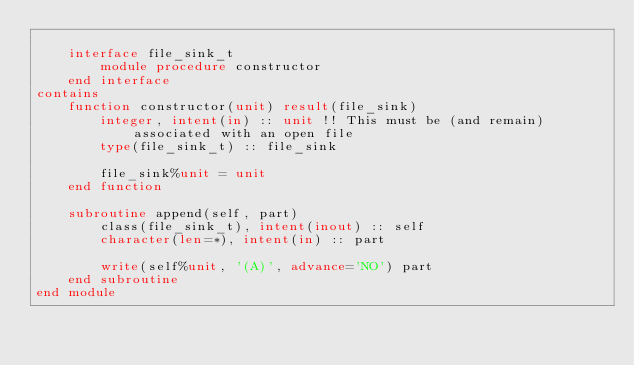<code> <loc_0><loc_0><loc_500><loc_500><_FORTRAN_>
    interface file_sink_t
        module procedure constructor
    end interface
contains
    function constructor(unit) result(file_sink)
        integer, intent(in) :: unit !! This must be (and remain) associated with an open file
        type(file_sink_t) :: file_sink

        file_sink%unit = unit
    end function

    subroutine append(self, part)
        class(file_sink_t), intent(inout) :: self
        character(len=*), intent(in) :: part

        write(self%unit, '(A)', advance='NO') part
    end subroutine
end module
</code> 